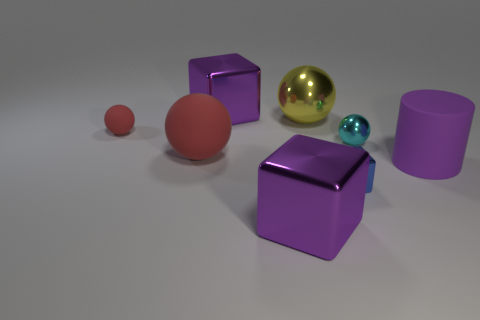Is there anything else that is the same shape as the purple matte thing?
Provide a succinct answer. No. Do the cyan thing and the small blue thing have the same shape?
Make the answer very short. No. What shape is the big rubber object that is the same color as the tiny matte thing?
Provide a succinct answer. Sphere. Do the cyan object and the purple thing in front of the cylinder have the same size?
Your answer should be compact. No. What color is the ball that is both behind the cyan object and right of the small red matte object?
Offer a very short reply. Yellow. Is the number of blue cubes that are right of the small metallic cube greater than the number of big purple metallic objects left of the small red ball?
Keep it short and to the point. No. There is a yellow thing that is the same material as the tiny cyan sphere; what is its size?
Make the answer very short. Large. There is a purple object behind the yellow ball; what number of large balls are on the left side of it?
Offer a very short reply. 1. Is there a large purple thing of the same shape as the small blue object?
Keep it short and to the point. Yes. There is a big matte object that is on the left side of the purple block that is behind the tiny red matte ball; what is its color?
Your answer should be compact. Red. 